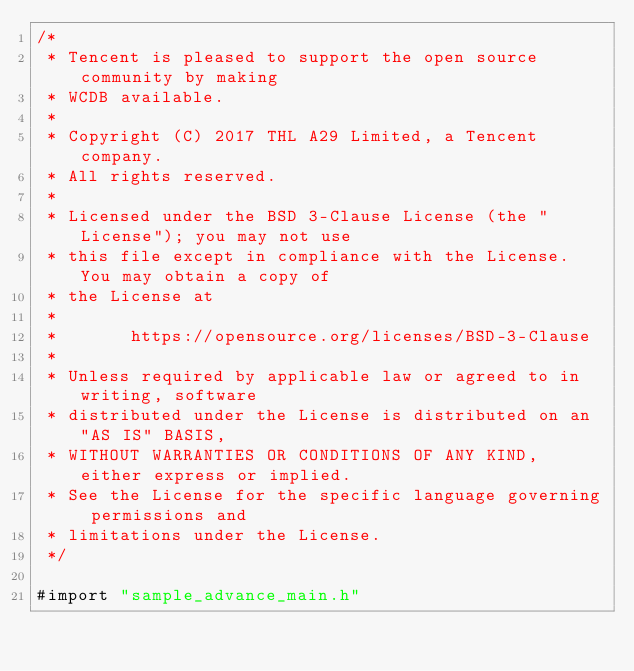<code> <loc_0><loc_0><loc_500><loc_500><_ObjectiveC_>/*
 * Tencent is pleased to support the open source community by making
 * WCDB available.
 *
 * Copyright (C) 2017 THL A29 Limited, a Tencent company.
 * All rights reserved.
 *
 * Licensed under the BSD 3-Clause License (the "License"); you may not use
 * this file except in compliance with the License. You may obtain a copy of
 * the License at
 *
 *       https://opensource.org/licenses/BSD-3-Clause
 *
 * Unless required by applicable law or agreed to in writing, software
 * distributed under the License is distributed on an "AS IS" BASIS,
 * WITHOUT WARRANTIES OR CONDITIONS OF ANY KIND, either express or implied.
 * See the License for the specific language governing permissions and
 * limitations under the License.
 */

#import "sample_advance_main.h"</code> 